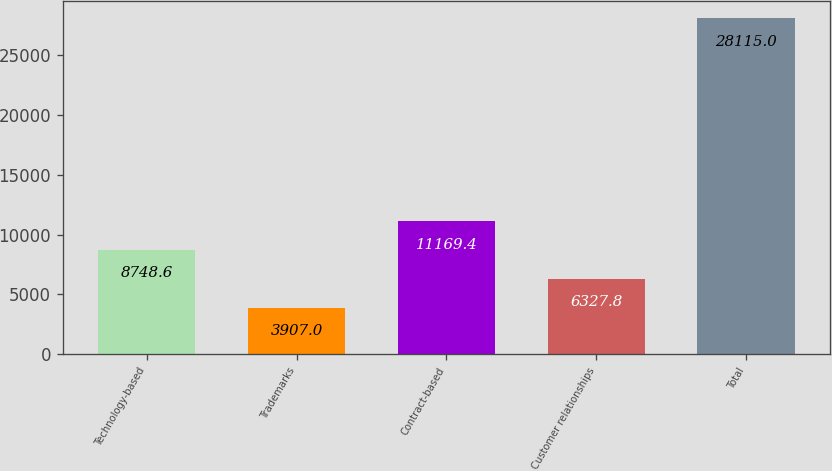Convert chart. <chart><loc_0><loc_0><loc_500><loc_500><bar_chart><fcel>Technology-based<fcel>Trademarks<fcel>Contract-based<fcel>Customer relationships<fcel>Total<nl><fcel>8748.6<fcel>3907<fcel>11169.4<fcel>6327.8<fcel>28115<nl></chart> 